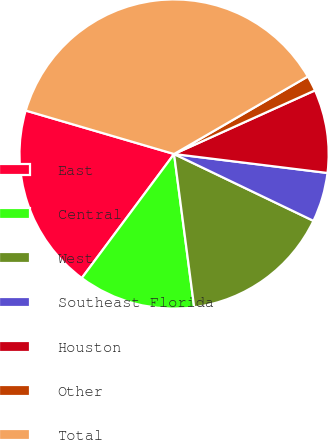Convert chart to OTSL. <chart><loc_0><loc_0><loc_500><loc_500><pie_chart><fcel>East<fcel>Central<fcel>West<fcel>Southeast Florida<fcel>Houston<fcel>Other<fcel>Total<nl><fcel>19.36%<fcel>12.26%<fcel>15.81%<fcel>5.16%<fcel>8.71%<fcel>1.61%<fcel>37.11%<nl></chart> 